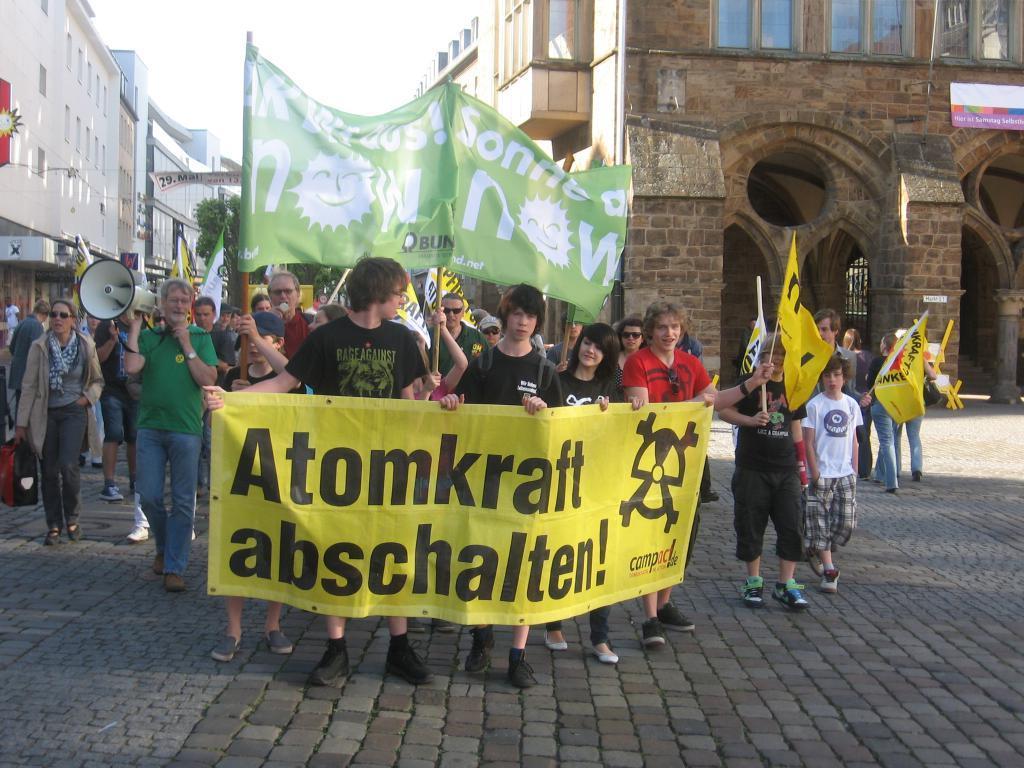Please provide a concise description of this image. This is the picture of a road. In this image there are group of people holding the banner and flags and walking on the road. On the left side of the image there is a person with green t-shirt is holding the speaker and walking. At the back there are buildings and trees and there are hoardings on the buildings. At the top there is sky. At the bottom there is a road. 